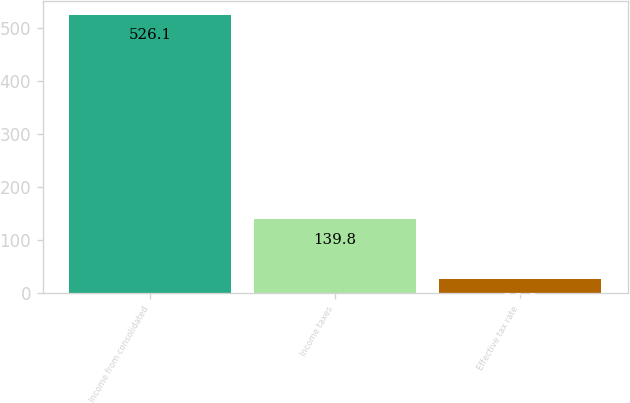Convert chart. <chart><loc_0><loc_0><loc_500><loc_500><bar_chart><fcel>Income from consolidated<fcel>Income taxes<fcel>Effective tax rate<nl><fcel>526.1<fcel>139.8<fcel>26.6<nl></chart> 